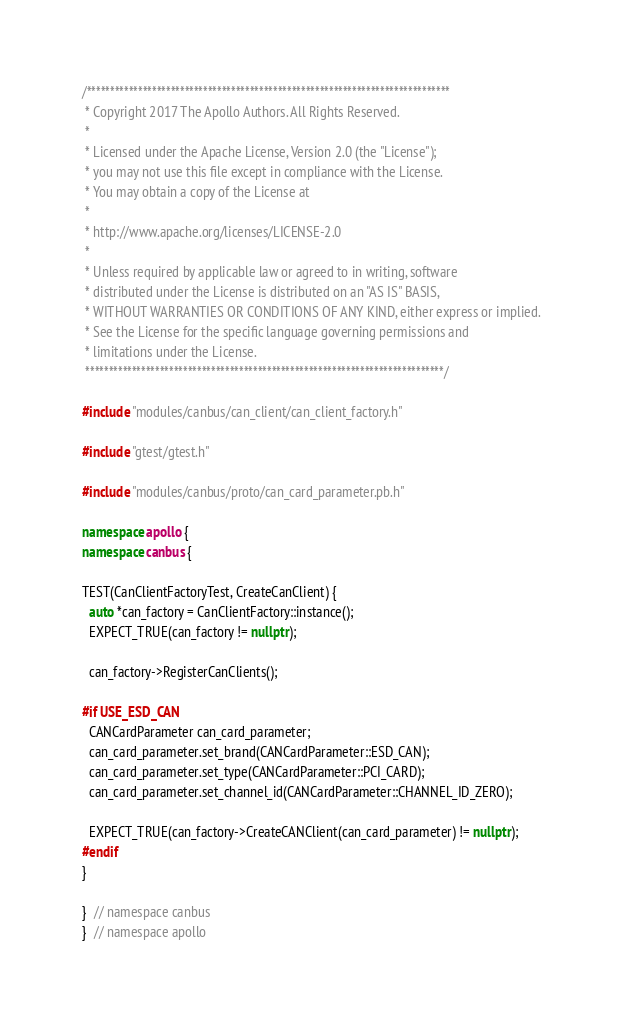<code> <loc_0><loc_0><loc_500><loc_500><_C++_>/******************************************************************************
 * Copyright 2017 The Apollo Authors. All Rights Reserved.
 *
 * Licensed under the Apache License, Version 2.0 (the "License");
 * you may not use this file except in compliance with the License.
 * You may obtain a copy of the License at
 *
 * http://www.apache.org/licenses/LICENSE-2.0
 *
 * Unless required by applicable law or agreed to in writing, software
 * distributed under the License is distributed on an "AS IS" BASIS,
 * WITHOUT WARRANTIES OR CONDITIONS OF ANY KIND, either express or implied.
 * See the License for the specific language governing permissions and
 * limitations under the License.
 *****************************************************************************/

#include "modules/canbus/can_client/can_client_factory.h"

#include "gtest/gtest.h"

#include "modules/canbus/proto/can_card_parameter.pb.h"

namespace apollo {
namespace canbus {

TEST(CanClientFactoryTest, CreateCanClient) {
  auto *can_factory = CanClientFactory::instance();
  EXPECT_TRUE(can_factory != nullptr);

  can_factory->RegisterCanClients();

#if USE_ESD_CAN
  CANCardParameter can_card_parameter;
  can_card_parameter.set_brand(CANCardParameter::ESD_CAN);
  can_card_parameter.set_type(CANCardParameter::PCI_CARD);
  can_card_parameter.set_channel_id(CANCardParameter::CHANNEL_ID_ZERO);

  EXPECT_TRUE(can_factory->CreateCANClient(can_card_parameter) != nullptr);
#endif
}

}  // namespace canbus
}  // namespace apollo
</code> 